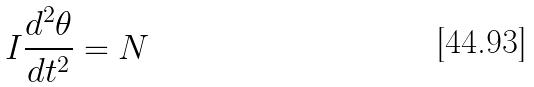Convert formula to latex. <formula><loc_0><loc_0><loc_500><loc_500>I \frac { d ^ { 2 } \theta } { d t ^ { 2 } } = N</formula> 